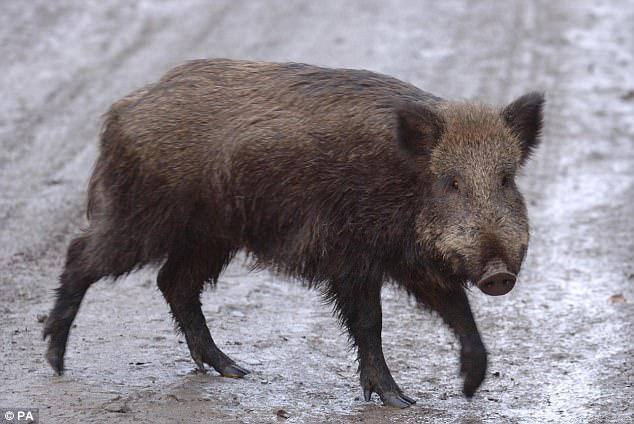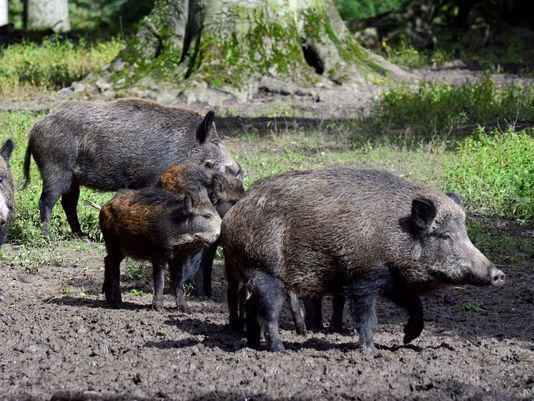The first image is the image on the left, the second image is the image on the right. For the images displayed, is the sentence "There are at least two baby boars in the image on the right" factually correct? Answer yes or no. Yes. The first image is the image on the left, the second image is the image on the right. Assess this claim about the two images: "Right image shows young and adult hogs.". Correct or not? Answer yes or no. Yes. 